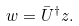Convert formula to latex. <formula><loc_0><loc_0><loc_500><loc_500>w = \bar { U } ^ { \dagger } z .</formula> 